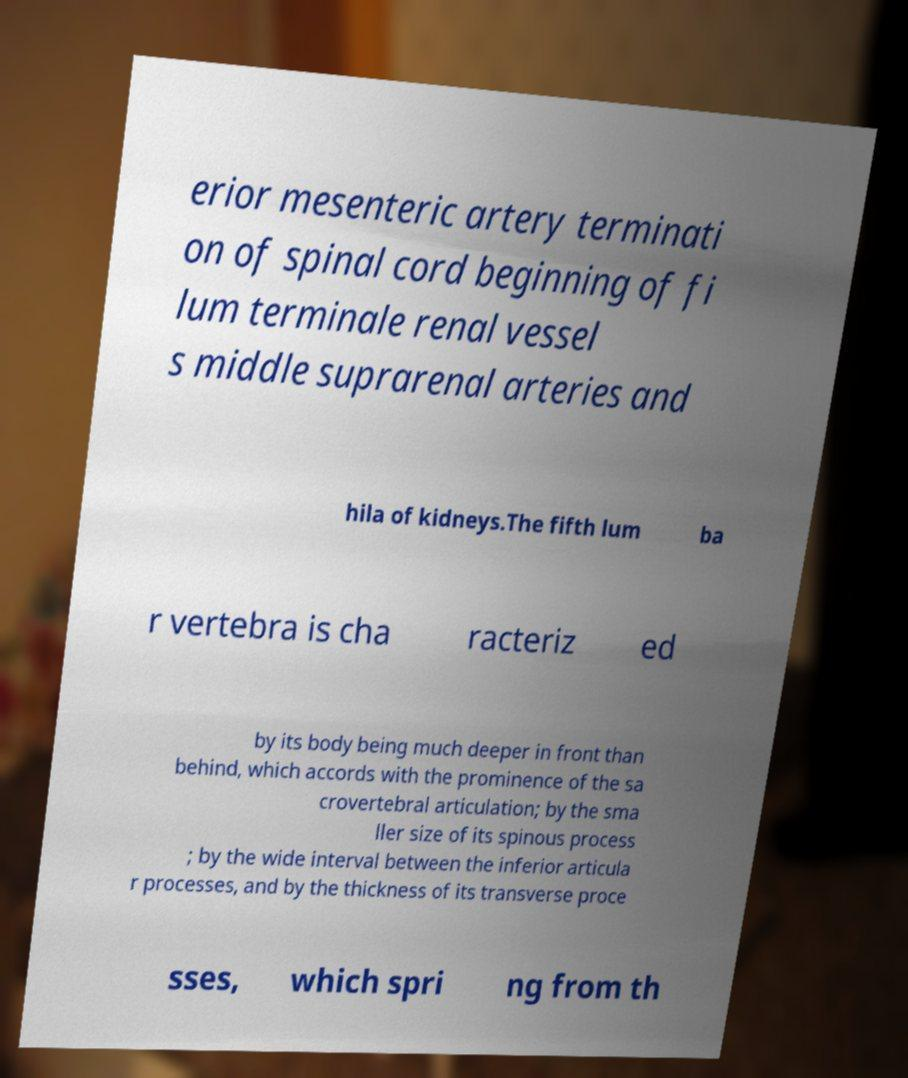Can you accurately transcribe the text from the provided image for me? erior mesenteric artery terminati on of spinal cord beginning of fi lum terminale renal vessel s middle suprarenal arteries and hila of kidneys.The fifth lum ba r vertebra is cha racteriz ed by its body being much deeper in front than behind, which accords with the prominence of the sa crovertebral articulation; by the sma ller size of its spinous process ; by the wide interval between the inferior articula r processes, and by the thickness of its transverse proce sses, which spri ng from th 